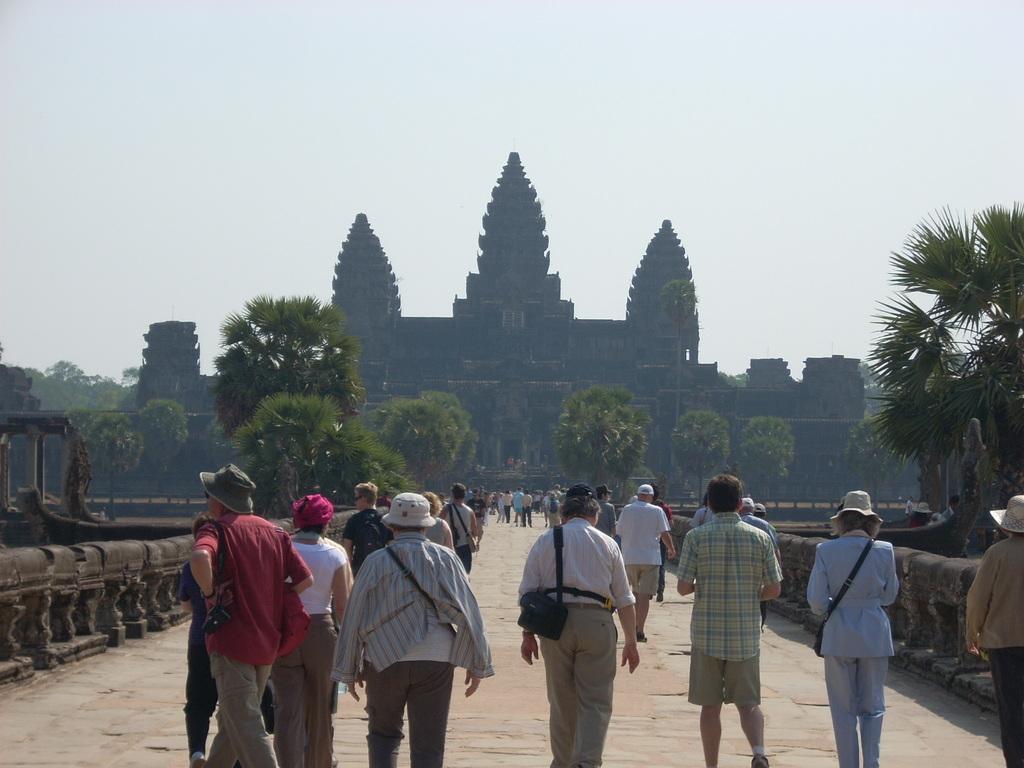Can you describe this image briefly? In this image we can see a group of persons are walking on the ground, in front there is a building, there are trees, there is a sky. 